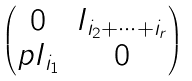<formula> <loc_0><loc_0><loc_500><loc_500>\begin{pmatrix} 0 & I _ { i _ { 2 } + \dots + i _ { r } } \\ p I _ { i _ { 1 } } & 0 \end{pmatrix}</formula> 